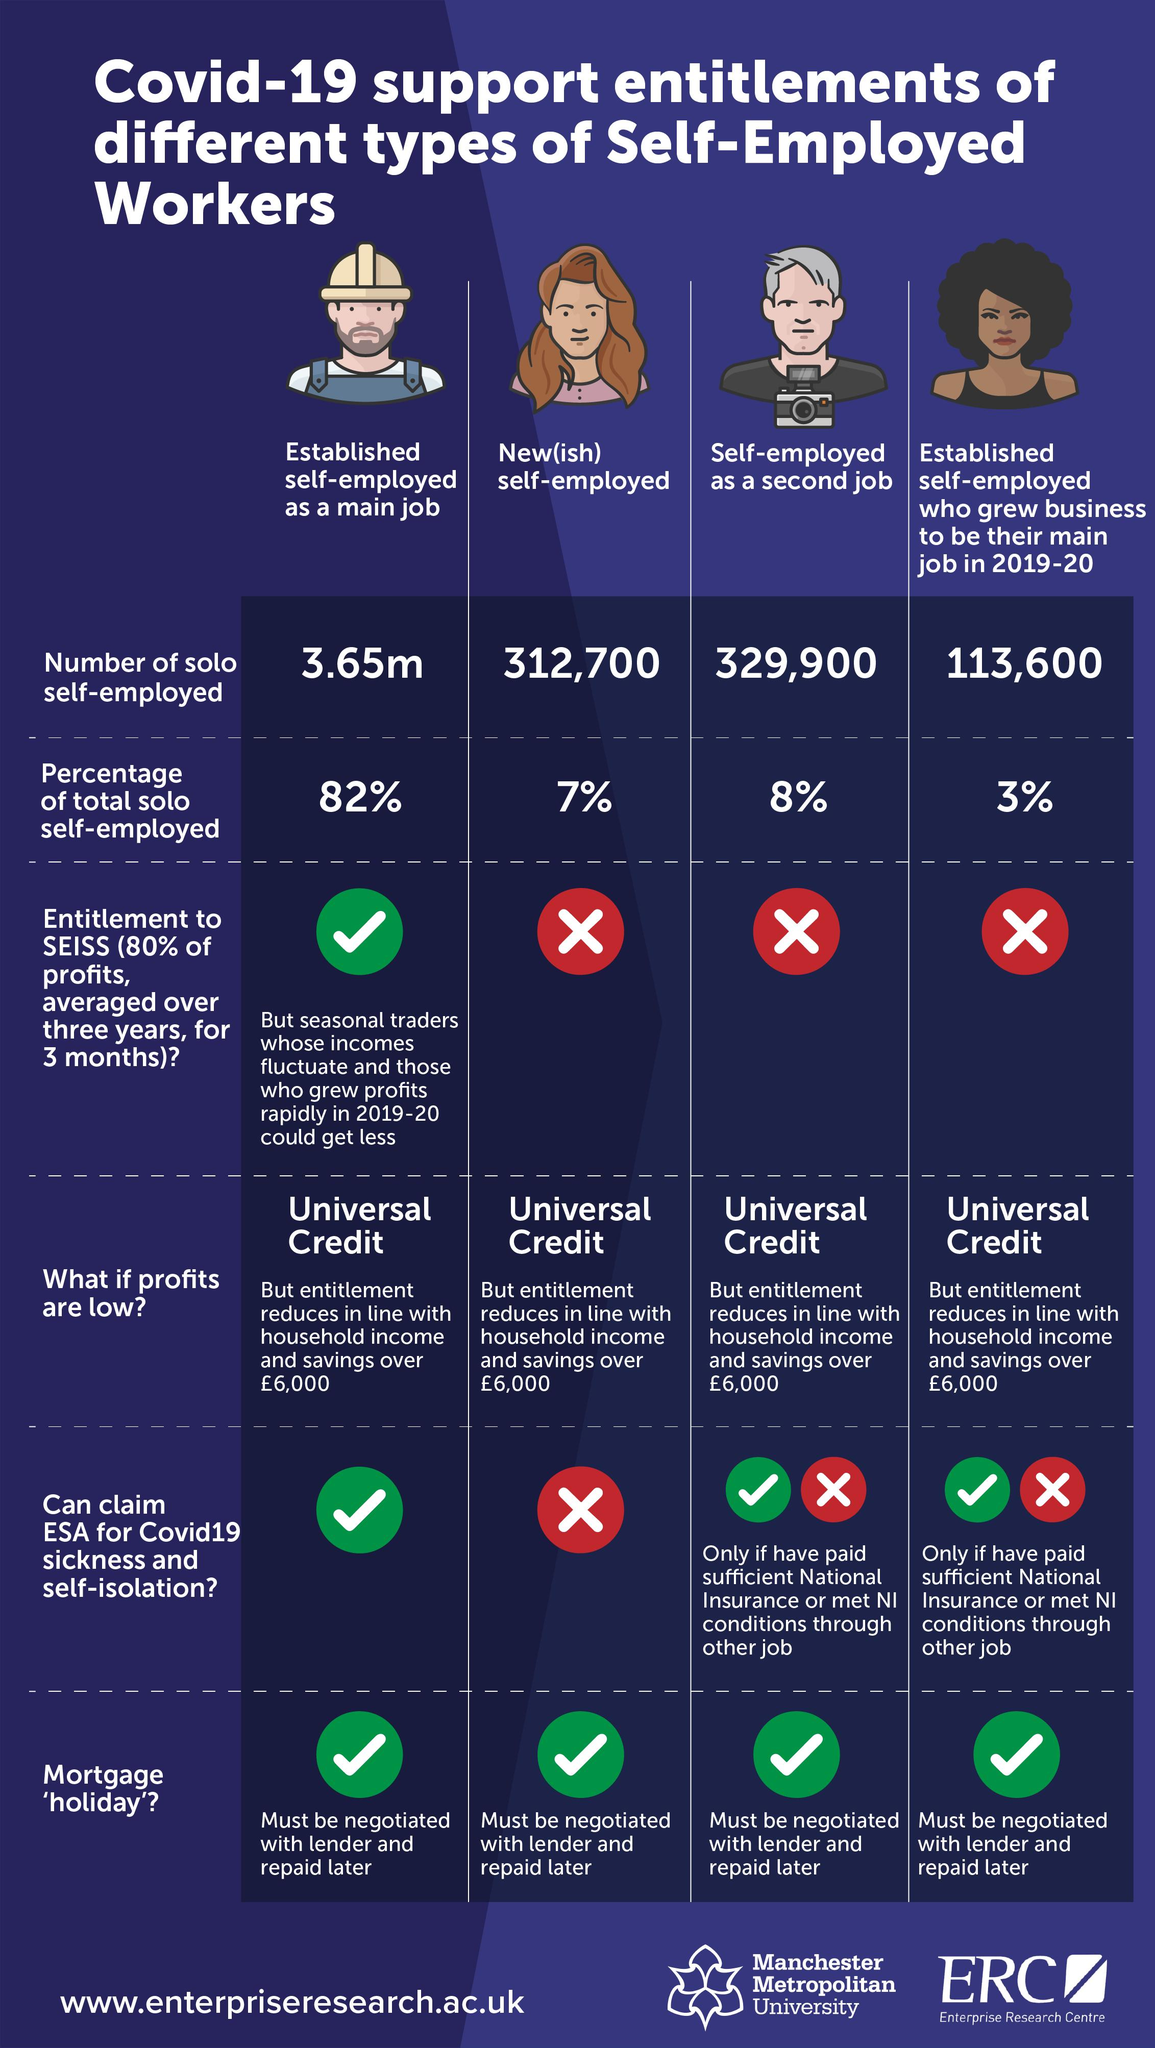Draw attention to some important aspects in this diagram. The establishment of self-employment as the primary job for workers in a particular category is the highest among that category. The total count of new self-employed workers and people who are self-employed as a second job is 642,600. There are a total of 8 green tick symbols present in this infographic. There are four distinct categories of self-employed workers listed in the table. It is possible for someone who is established self-employed and considers it their main job to claim ESA for COVID-19 without any conditions. 